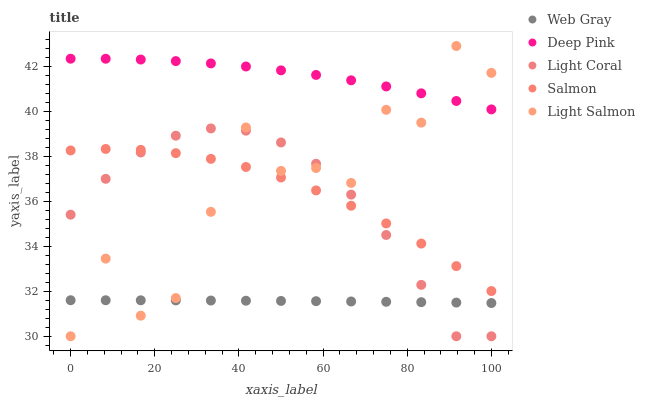Does Web Gray have the minimum area under the curve?
Answer yes or no. Yes. Does Deep Pink have the maximum area under the curve?
Answer yes or no. Yes. Does Light Salmon have the minimum area under the curve?
Answer yes or no. No. Does Light Salmon have the maximum area under the curve?
Answer yes or no. No. Is Web Gray the smoothest?
Answer yes or no. Yes. Is Light Salmon the roughest?
Answer yes or no. Yes. Is Light Salmon the smoothest?
Answer yes or no. No. Is Web Gray the roughest?
Answer yes or no. No. Does Light Coral have the lowest value?
Answer yes or no. Yes. Does Web Gray have the lowest value?
Answer yes or no. No. Does Light Salmon have the highest value?
Answer yes or no. Yes. Does Web Gray have the highest value?
Answer yes or no. No. Is Web Gray less than Salmon?
Answer yes or no. Yes. Is Salmon greater than Web Gray?
Answer yes or no. Yes. Does Light Salmon intersect Salmon?
Answer yes or no. Yes. Is Light Salmon less than Salmon?
Answer yes or no. No. Is Light Salmon greater than Salmon?
Answer yes or no. No. Does Web Gray intersect Salmon?
Answer yes or no. No. 